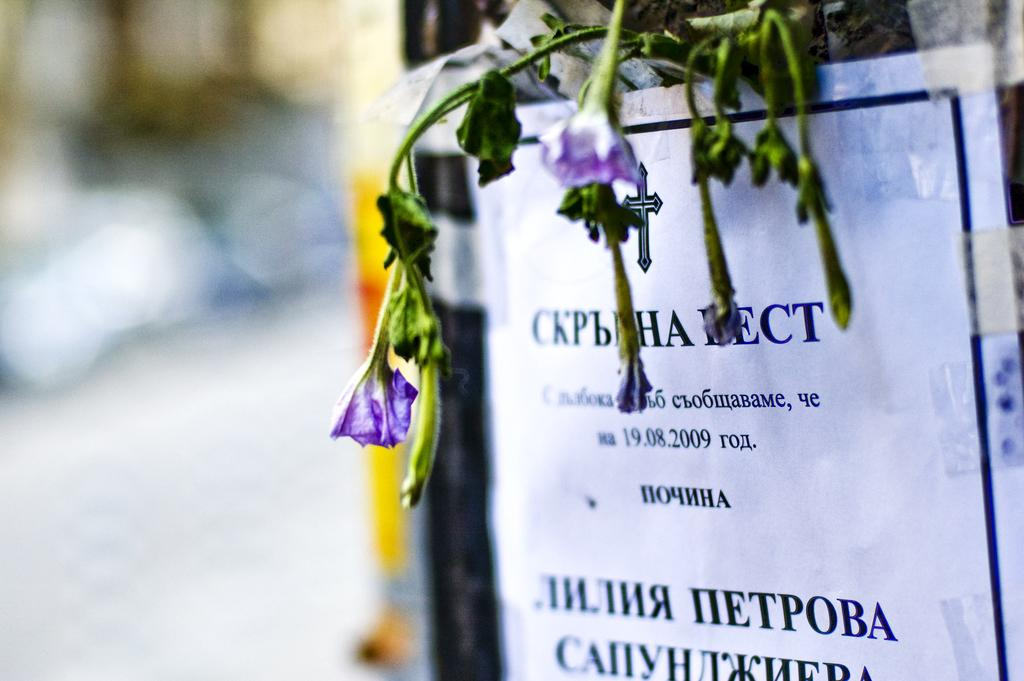What is on the paper that is visible in the image? There is a paper with printed text in the image. What can be seen above the paper on a wall? There are flowers above the paper on a wall. Can you describe the background of the image? The background of the image is blurry. What type of oatmeal is being served in the image? There is no oatmeal present in the image. What color is the lipstick on the person's lips in the image? There are no people or lips visible in the image. 